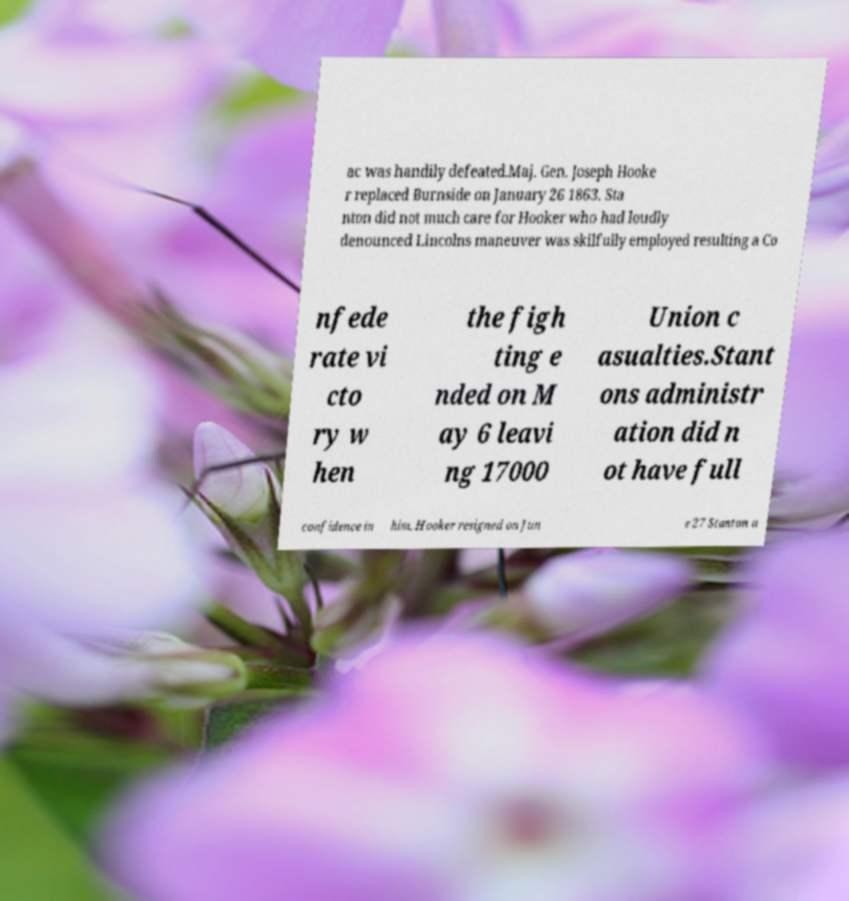Could you assist in decoding the text presented in this image and type it out clearly? ac was handily defeated.Maj. Gen. Joseph Hooke r replaced Burnside on January 26 1863. Sta nton did not much care for Hooker who had loudly denounced Lincolns maneuver was skilfully employed resulting a Co nfede rate vi cto ry w hen the figh ting e nded on M ay 6 leavi ng 17000 Union c asualties.Stant ons administr ation did n ot have full confidence in him. Hooker resigned on Jun e 27 Stanton a 